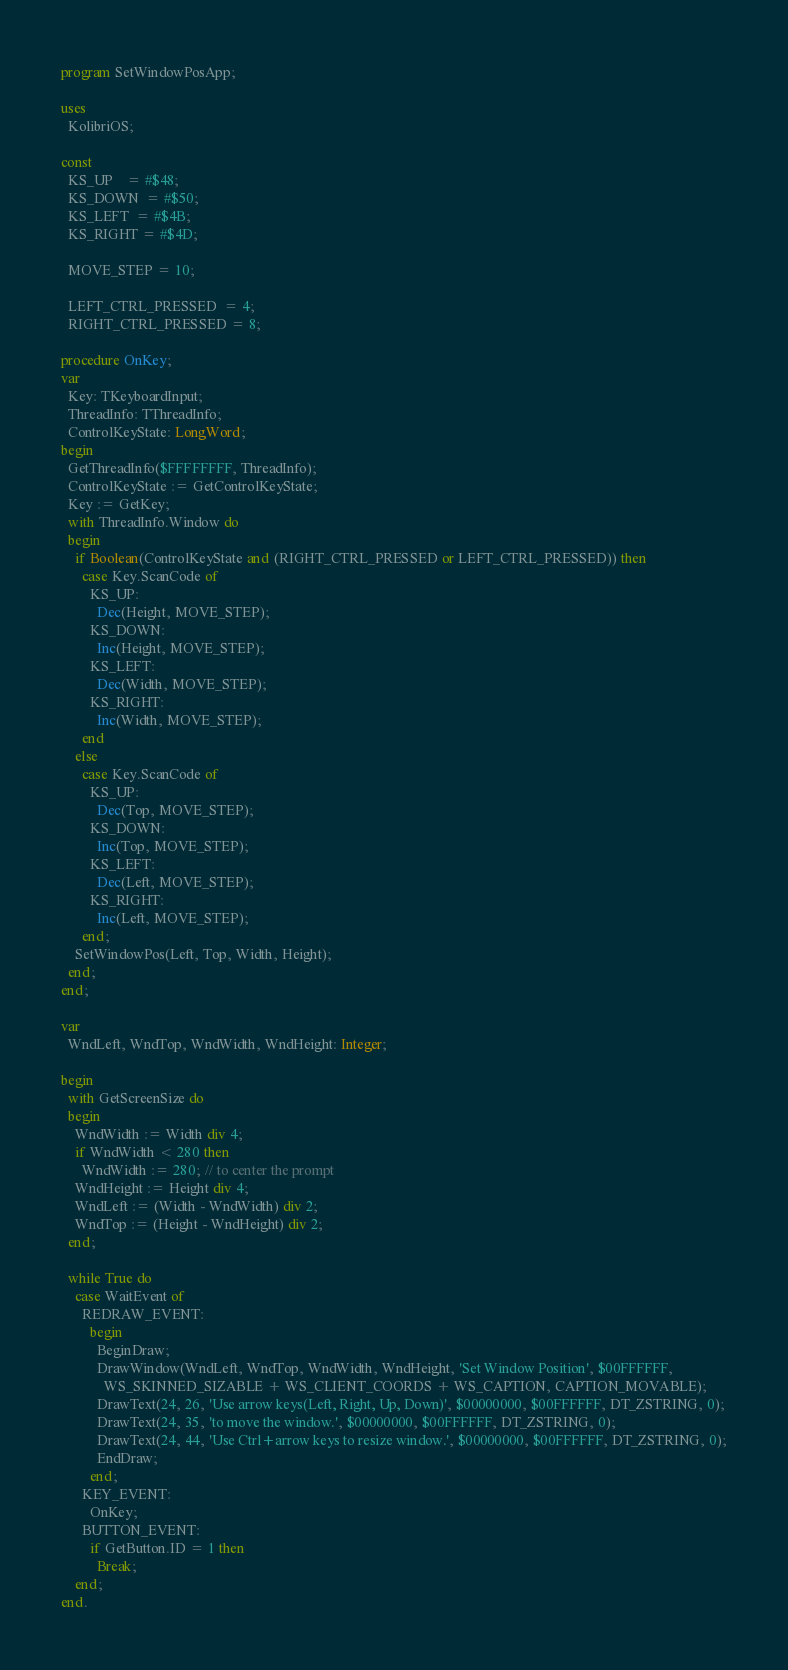<code> <loc_0><loc_0><loc_500><loc_500><_Pascal_>program SetWindowPosApp;

uses
  KolibriOS;

const
  KS_UP    = #$48;
  KS_DOWN  = #$50;
  KS_LEFT  = #$4B;
  KS_RIGHT = #$4D;

  MOVE_STEP = 10;

  LEFT_CTRL_PRESSED  = 4;
  RIGHT_CTRL_PRESSED = 8; 

procedure OnKey;
var
  Key: TKeyboardInput;
  ThreadInfo: TThreadInfo;
  ControlKeyState: LongWord;
begin  
  GetThreadInfo($FFFFFFFF, ThreadInfo);
  ControlKeyState := GetControlKeyState;
  Key := GetKey;
  with ThreadInfo.Window do
  begin
    if Boolean(ControlKeyState and (RIGHT_CTRL_PRESSED or LEFT_CTRL_PRESSED)) then
      case Key.ScanCode of
        KS_UP:
          Dec(Height, MOVE_STEP);
        KS_DOWN:
          Inc(Height, MOVE_STEP);
        KS_LEFT:
          Dec(Width, MOVE_STEP);
        KS_RIGHT:
          Inc(Width, MOVE_STEP);
      end
    else
      case Key.ScanCode of
        KS_UP:
          Dec(Top, MOVE_STEP);
        KS_DOWN:
          Inc(Top, MOVE_STEP);
        KS_LEFT:
          Dec(Left, MOVE_STEP);
        KS_RIGHT:
          Inc(Left, MOVE_STEP);
      end;
    SetWindowPos(Left, Top, Width, Height);
  end;  
end;

var
  WndLeft, WndTop, WndWidth, WndHeight: Integer;

begin
  with GetScreenSize do
  begin
    WndWidth := Width div 4;
    if WndWidth < 280 then
      WndWidth := 280; // to center the prompt
    WndHeight := Height div 4;
    WndLeft := (Width - WndWidth) div 2;
    WndTop := (Height - WndHeight) div 2;
  end;

  while True do
    case WaitEvent of
      REDRAW_EVENT:
        begin
          BeginDraw;
          DrawWindow(WndLeft, WndTop, WndWidth, WndHeight, 'Set Window Position', $00FFFFFF,
            WS_SKINNED_SIZABLE + WS_CLIENT_COORDS + WS_CAPTION, CAPTION_MOVABLE);
          DrawText(24, 26, 'Use arrow keys(Left, Right, Up, Down)', $00000000, $00FFFFFF, DT_ZSTRING, 0);
          DrawText(24, 35, 'to move the window.', $00000000, $00FFFFFF, DT_ZSTRING, 0);
          DrawText(24, 44, 'Use Ctrl+arrow keys to resize window.', $00000000, $00FFFFFF, DT_ZSTRING, 0);
          EndDraw;
        end;
      KEY_EVENT:
        OnKey;
      BUTTON_EVENT:
        if GetButton.ID = 1 then
          Break;
    end;
end.
</code> 